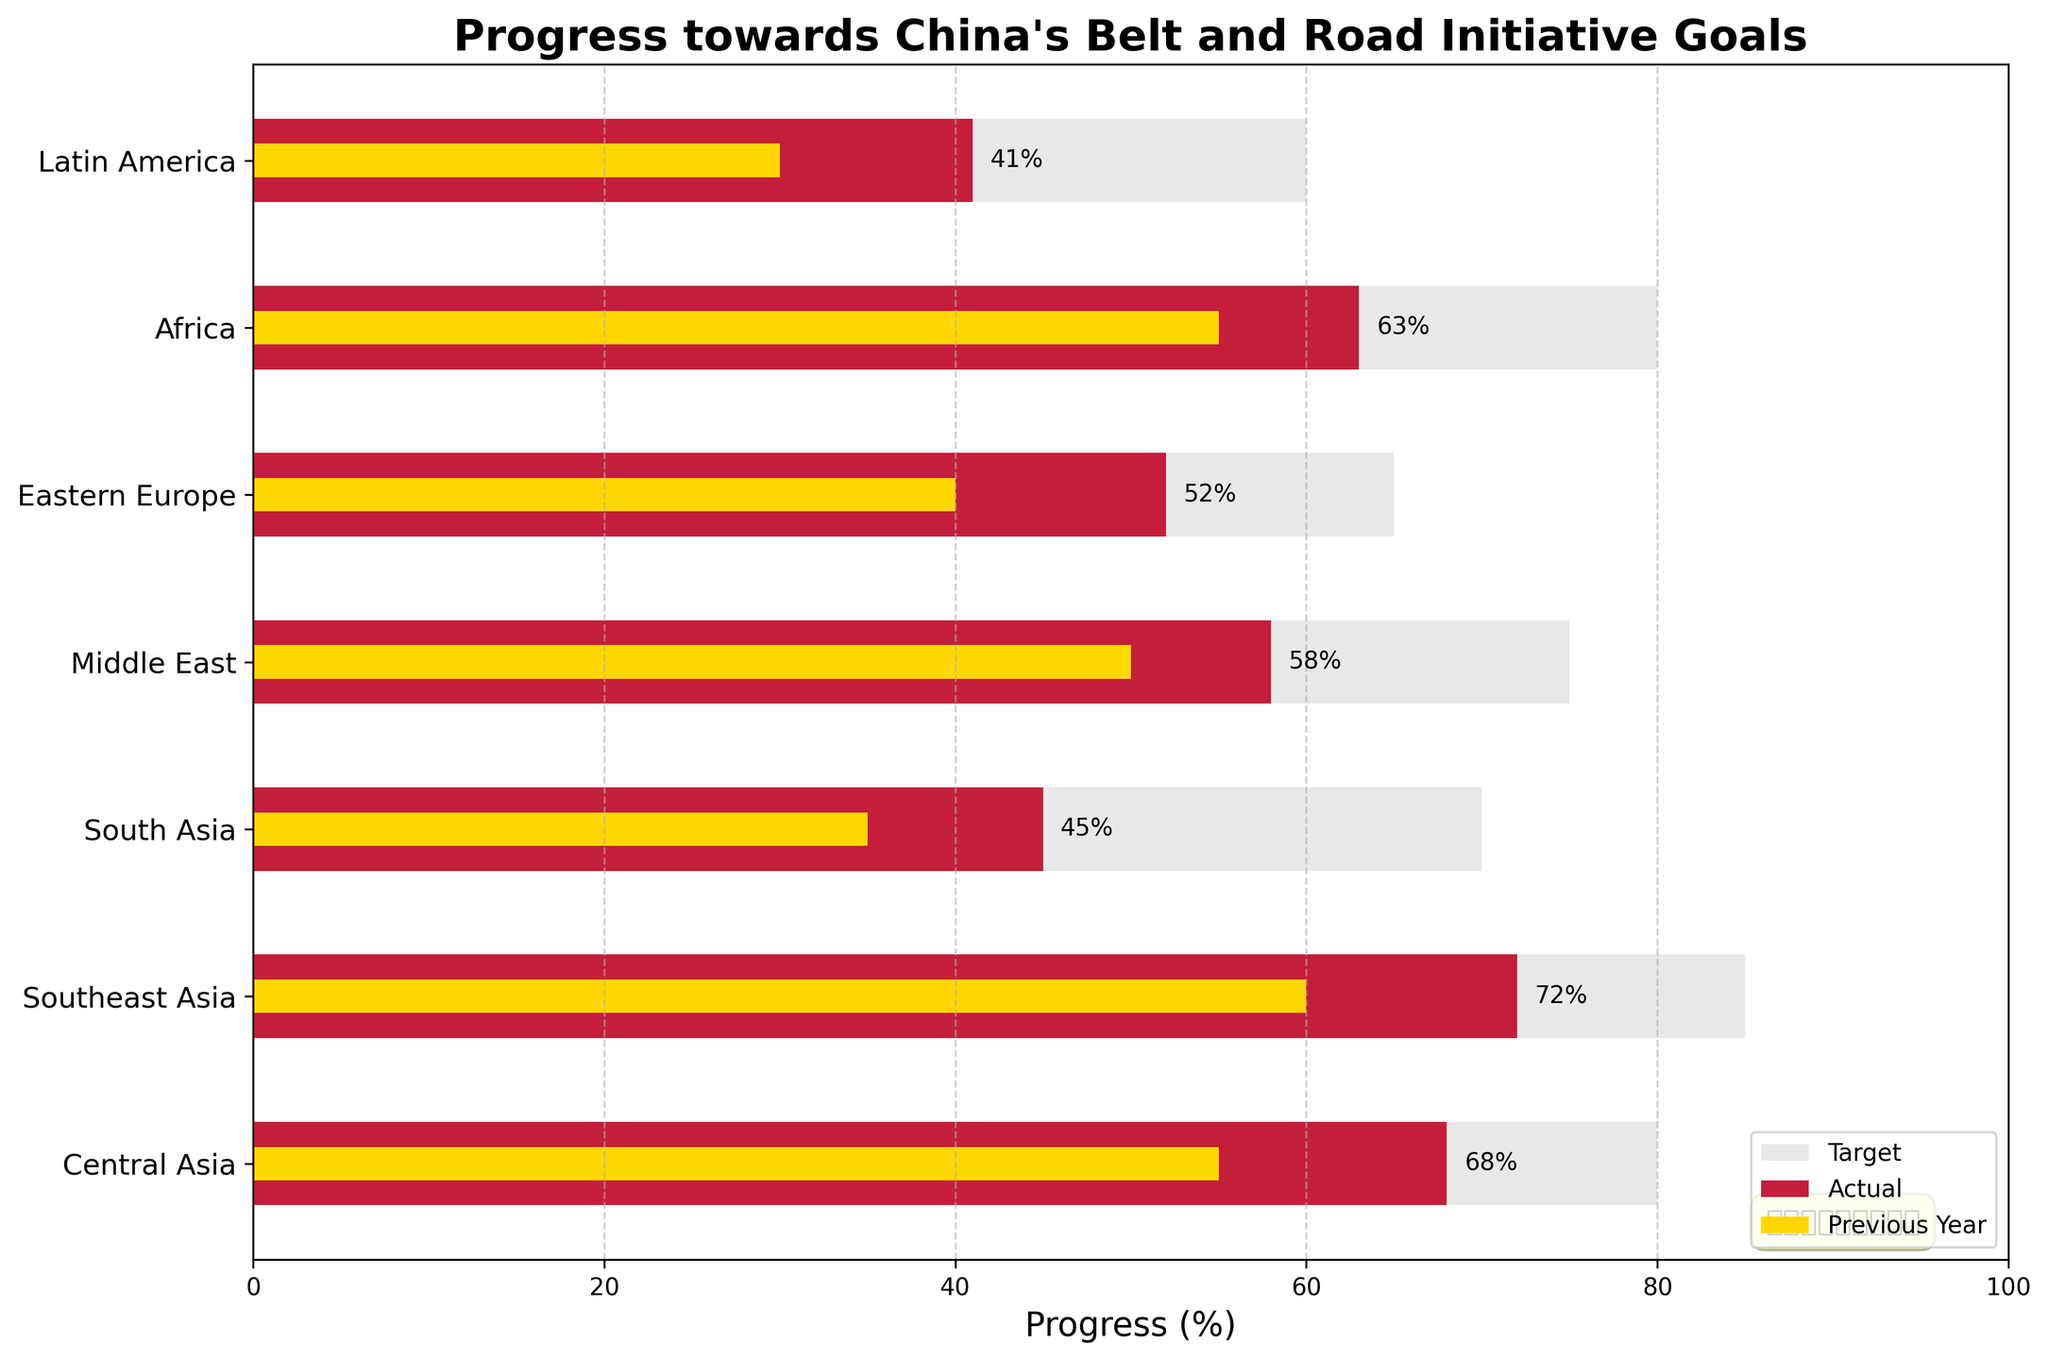What is the title of the chart? The title is usually located at the top of the chart and provides a summary of what the chart is about.
Answer: Progress towards China's Belt and Road Initiative Goals Which region has the highest actual progress towards the goal? By looking at the length of the red bars, identify the longest one which represents the highest actual progress.
Answer: Southeast Asia What is the difference between the target and the actual progress in South Asia? Subtract the actual progress from the target for South Asia: 70 - 45 = 25.
Answer: 25 How does the progress in the previous year for Central Asia compare with its actual progress this year? Compare the length of the yellow bar with the red bar for Central Asia to see which is longer. Central Asia's previous year progress is 55%, and the actual progress this year is 68%.
Answer: The actual progress this year is higher Which regions have their actual progress over 50%? Identify the regions where the red bar exceeds the 50% mark: Central Asia, Southeast Asia, Middle East, Eastern Europe, and Africa.
Answer: Central Asia, Southeast Asia, Middle East, Eastern Europe, and Africa What is the average actual progress of all regions? Sum up all actual progress values then divide by the number of regions. (68 + 72 + 45 + 58 + 52 + 63 + 41) / 7 = 399 / 7 ≈ 57
Answer: 57 Which region has the smallest gap between previous year’s progress and this year's actual progress? Calculate the difference for each region and find the smallest one: Central Asia (68-55=13), Southeast Asia (72-60=12), South Asia (45-35=10), Middle East (58-50=8), Eastern Europe (52-40=12), Africa (63-55=8), Latin America (41-30=11). The smallest gap is for Middle East and Africa, both 8.
Answer: Middle East and Africa In which region was the target furthest from the actual progress? Calculate the difference between target and actual progress for each region and identify the largest gap: Central Asia (80-68=12), Southeast Asia (85-72=13), South Asia (70-45=25), Middle East (75-58=17), Eastern Europe (65-52=13), Africa (80-63=17), Latin America (60-41=19).
Answer: South Asia What color represents the previous year's data? Observe the legend and identify the color assigned to the previous year.
Answer: Yellow Which region has the closest actual progress to 60%? Compare the actual progress numbers and find the one closest to 60%.
Answer: Southeast Asia 